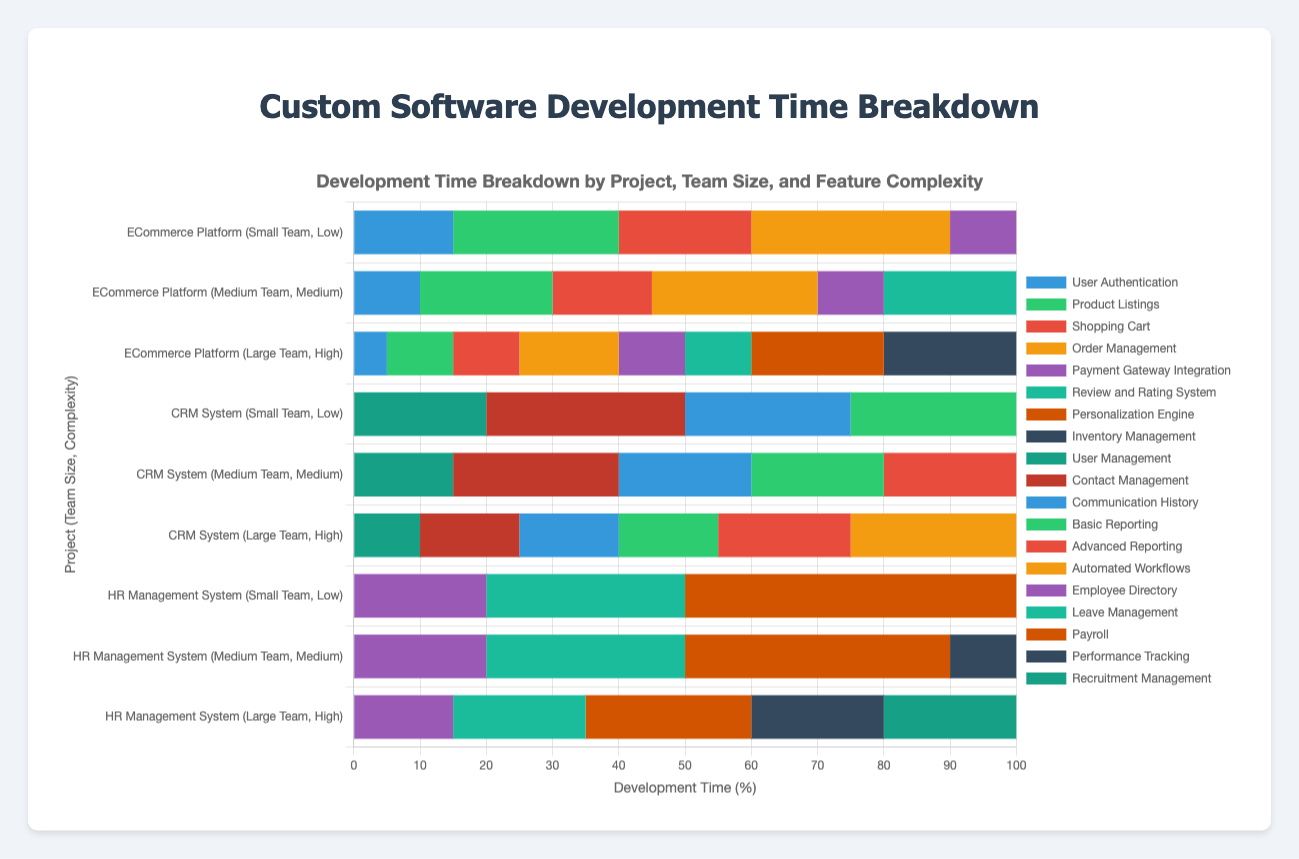What project has the highest percentage of time allocated to a single feature? Look at the bars corresponding to each project and identify which single feature takes up the largest portion. The "HR Management System" (Small Team, Low Complexity) has the "Payroll" feature occupying 50%, which is the largest single feature time allocation.
Answer: HR Management System (Small Team, Low Complexity) How does the development time for "Order Management" compare between the ECommerce Platform for a Small Team and a Medium Team? Examine the respective bars for the ECommerce Platform with Small and Medium Teams. The "Order Management" for a Small Team is at 30%, while for a Medium Team, it is at 25%.
Answer: 5% greater for Small Team What is the combined development time percentage for "Product Listings" in the ECommerce Platform across all team compositions? Add up the individual percentages for "Product Listings" in Small Team (25%), Medium Team (20%), and Large Team (10%). The combined time is 25% + 20% + 10% = 55%.
Answer: 55% Which feature takes up the most development time in the CRM System for a Large Team? For the CRM System with a Large Team, observe which bar segment is the largest. "Automated Workflows" occupies the largest segment with 25%.
Answer: Automated Workflows Between the project "HR Management System" for Medium and Large Teams, which has higher development time for "Recruitment Management"? Compare the segments for "Recruitment Management". It only appears in the "HR Management System" for Large Team with 20%. The Medium Team does not have this feature.
Answer: Higher for Large Team What is the percentage difference in development time for "User Authentication" between the ECommerce Platform with a Small Team and a Large Team? Subtract the percentage for "User Authentication" in a Large Team (5%) from that in a Small Team (15%). The difference is 15% - 5% = 10%.
Answer: 10% What is the total development time dedicated to "Leave Management" across all team compositions for the HR Management System? Add the development times for "Leave Management" across Small Team (30%), Medium Team (30%), and Large Team (20%). The total is 30% + 30% + 20% = 80%.
Answer: 80% Which team composition of the CRM System allocated the most time to "Basic Reporting"? Check the "Basic Reporting" segments for all CRM System team compositions. The Small Team allocated 25%, Medium Team allocated 20%, and Large Team allocated 15%. The Small Team allocated the most time.
Answer: Small Team Compare the total development time of the features related to reporting ("Basic Reporting" and "Advanced Reporting") in the CRM System for Medium Team. Sum the percentages for "Basic Reporting" (20%) and "Advanced Reporting" (20%). The total development time is 20% + 20% = 40%.
Answer: 40% What is the visual trend in development time allocation as team composition changes from Small to Large in the ECommerce Platform? Visually assess the trend from Small to Large Teams. Time allocated decreases for "User Authentication" and "Product Listings" while new features like "Personalization Engine" and "Inventory Management" appear in larger proportions.
Answer: Decreases for existing features, varying more with added features 